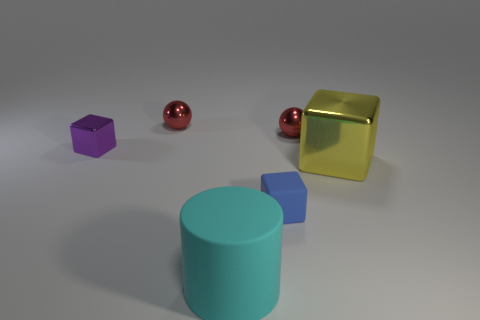Is the size of the ball left of the big cyan matte cylinder the same as the metallic cube that is on the left side of the large metal object?
Your answer should be very brief. Yes. What is the color of the tiny matte thing that is the same shape as the large yellow metal thing?
Ensure brevity in your answer.  Blue. Do the large yellow metallic object and the large matte object have the same shape?
Give a very brief answer. No. There is another metal thing that is the same shape as the yellow thing; what size is it?
Offer a very short reply. Small. How many other blue objects have the same material as the blue object?
Keep it short and to the point. 0. What number of objects are cyan shiny blocks or cyan matte objects?
Offer a terse response. 1. There is a small blue thing left of the large yellow metal cube; is there a ball that is in front of it?
Provide a short and direct response. No. Is the number of metallic cubes right of the purple block greater than the number of tiny matte cubes left of the large cyan matte cylinder?
Give a very brief answer. Yes. How many small cubes are the same color as the large matte thing?
Give a very brief answer. 0. Is the color of the shiny cube behind the large yellow shiny object the same as the block in front of the yellow metallic object?
Your answer should be very brief. No. 